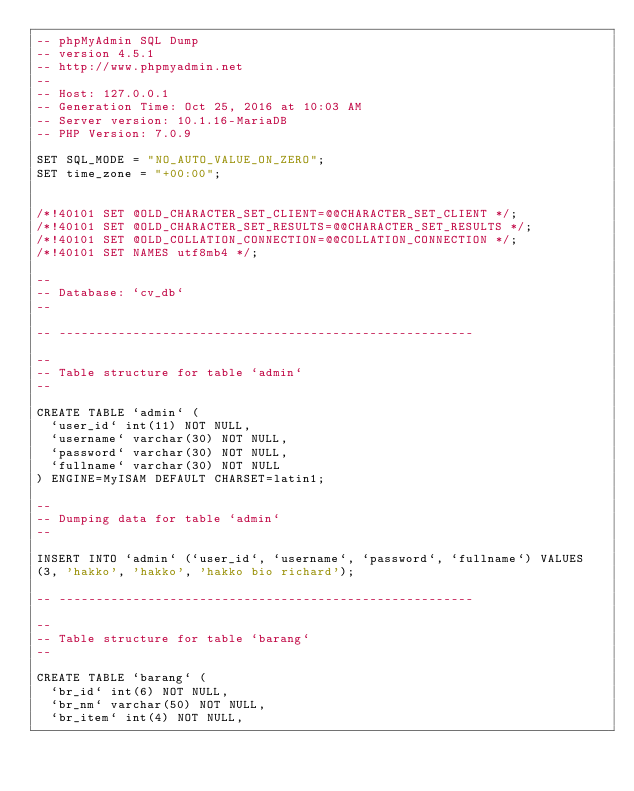Convert code to text. <code><loc_0><loc_0><loc_500><loc_500><_SQL_>-- phpMyAdmin SQL Dump
-- version 4.5.1
-- http://www.phpmyadmin.net
--
-- Host: 127.0.0.1
-- Generation Time: Oct 25, 2016 at 10:03 AM
-- Server version: 10.1.16-MariaDB
-- PHP Version: 7.0.9

SET SQL_MODE = "NO_AUTO_VALUE_ON_ZERO";
SET time_zone = "+00:00";


/*!40101 SET @OLD_CHARACTER_SET_CLIENT=@@CHARACTER_SET_CLIENT */;
/*!40101 SET @OLD_CHARACTER_SET_RESULTS=@@CHARACTER_SET_RESULTS */;
/*!40101 SET @OLD_COLLATION_CONNECTION=@@COLLATION_CONNECTION */;
/*!40101 SET NAMES utf8mb4 */;

--
-- Database: `cv_db`
--

-- --------------------------------------------------------

--
-- Table structure for table `admin`
--

CREATE TABLE `admin` (
  `user_id` int(11) NOT NULL,
  `username` varchar(30) NOT NULL,
  `password` varchar(30) NOT NULL,
  `fullname` varchar(30) NOT NULL
) ENGINE=MyISAM DEFAULT CHARSET=latin1;

--
-- Dumping data for table `admin`
--

INSERT INTO `admin` (`user_id`, `username`, `password`, `fullname`) VALUES
(3, 'hakko', 'hakko', 'hakko bio richard');

-- --------------------------------------------------------

--
-- Table structure for table `barang`
--

CREATE TABLE `barang` (
  `br_id` int(6) NOT NULL,
  `br_nm` varchar(50) NOT NULL,
  `br_item` int(4) NOT NULL,</code> 